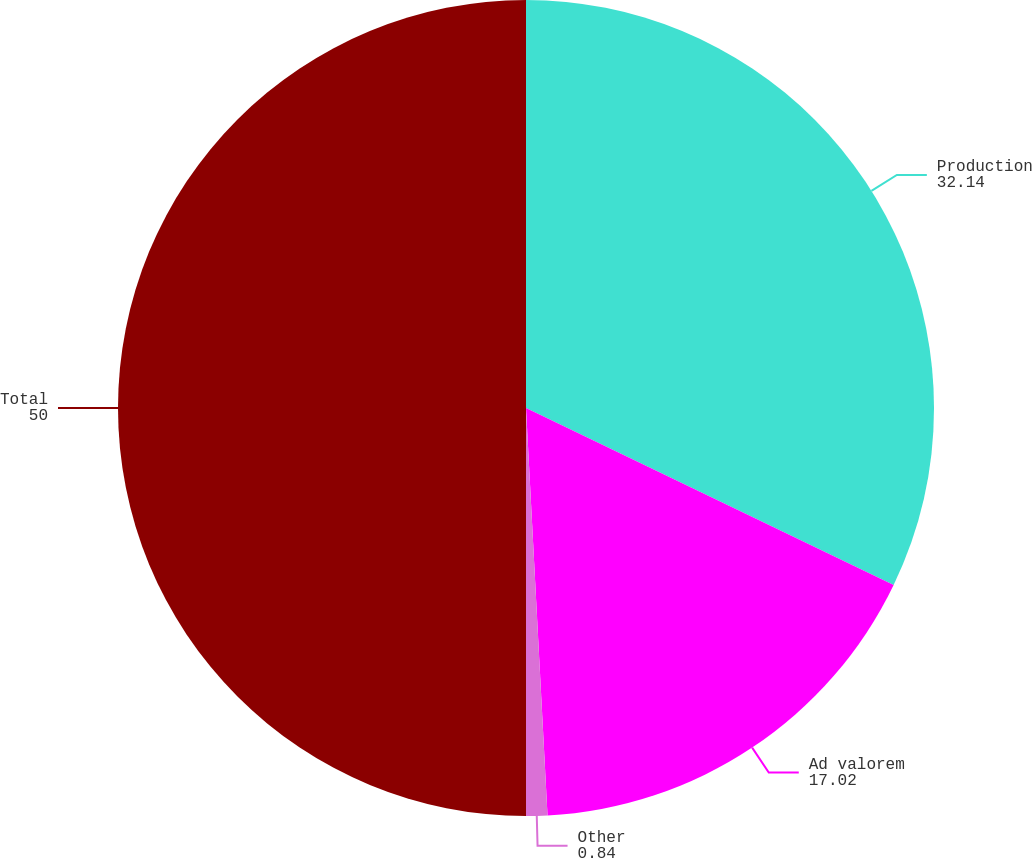Convert chart to OTSL. <chart><loc_0><loc_0><loc_500><loc_500><pie_chart><fcel>Production<fcel>Ad valorem<fcel>Other<fcel>Total<nl><fcel>32.14%<fcel>17.02%<fcel>0.84%<fcel>50.0%<nl></chart> 